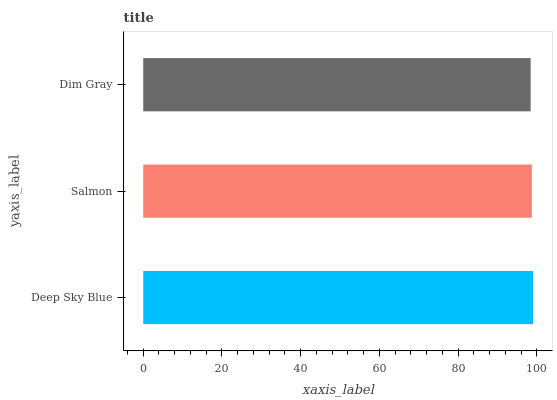Is Dim Gray the minimum?
Answer yes or no. Yes. Is Deep Sky Blue the maximum?
Answer yes or no. Yes. Is Salmon the minimum?
Answer yes or no. No. Is Salmon the maximum?
Answer yes or no. No. Is Deep Sky Blue greater than Salmon?
Answer yes or no. Yes. Is Salmon less than Deep Sky Blue?
Answer yes or no. Yes. Is Salmon greater than Deep Sky Blue?
Answer yes or no. No. Is Deep Sky Blue less than Salmon?
Answer yes or no. No. Is Salmon the high median?
Answer yes or no. Yes. Is Salmon the low median?
Answer yes or no. Yes. Is Dim Gray the high median?
Answer yes or no. No. Is Dim Gray the low median?
Answer yes or no. No. 